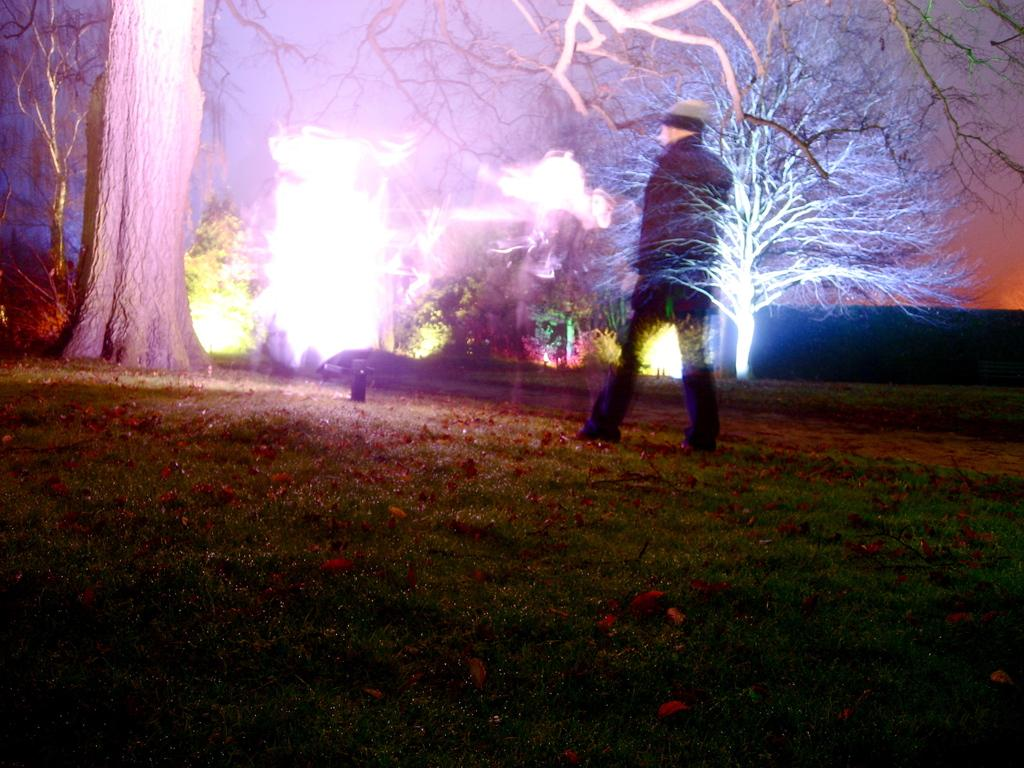What is the main subject of the image? There is a person in the image. What is the person wearing? The person is wearing a black dress. What is the person doing in the image? The person is walking on the grass. What can be seen on the ground in the image? There are dry leaves on the ground. What is visible in the background of the image? There are trees, lights, and the sky visible in the background. What type of crook can be seen in the image? There is no crook present in the image. What is the limit of the person's walking distance in the image? The image does not provide information about the person's walking distance, so it cannot be determined. 